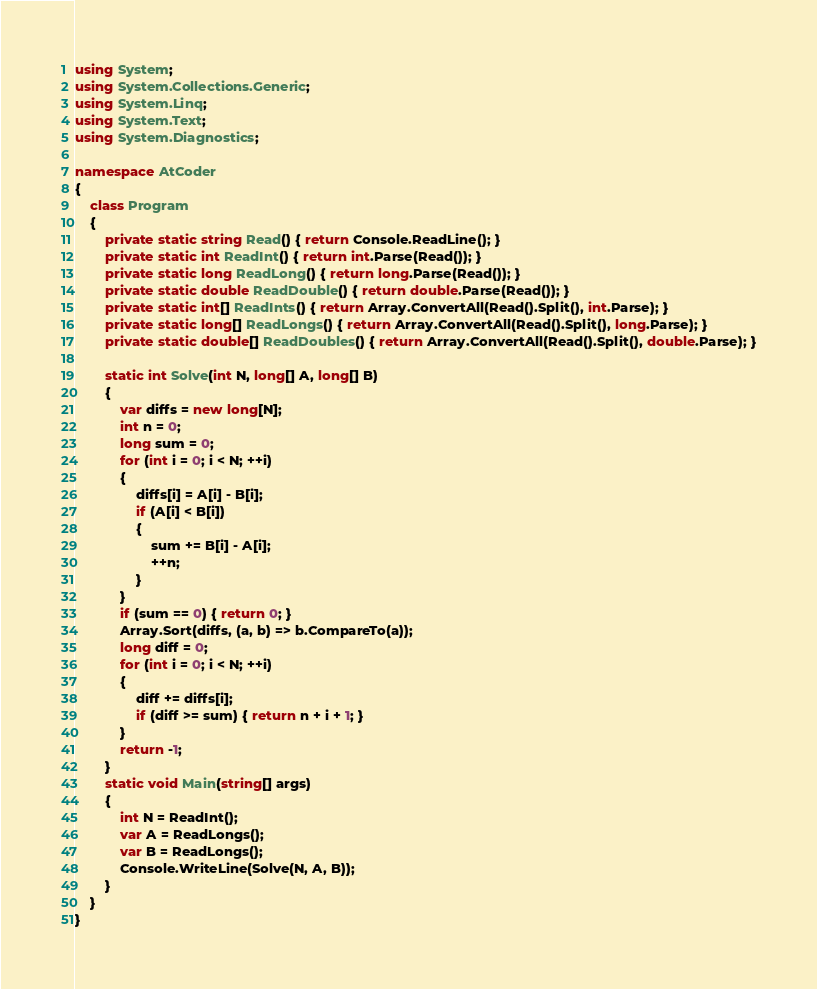Convert code to text. <code><loc_0><loc_0><loc_500><loc_500><_C#_>using System;
using System.Collections.Generic;
using System.Linq;
using System.Text;
using System.Diagnostics;

namespace AtCoder
{
    class Program
    {
        private static string Read() { return Console.ReadLine(); }
        private static int ReadInt() { return int.Parse(Read()); }
        private static long ReadLong() { return long.Parse(Read()); }
        private static double ReadDouble() { return double.Parse(Read()); }
        private static int[] ReadInts() { return Array.ConvertAll(Read().Split(), int.Parse); }
        private static long[] ReadLongs() { return Array.ConvertAll(Read().Split(), long.Parse); }
        private static double[] ReadDoubles() { return Array.ConvertAll(Read().Split(), double.Parse); }

        static int Solve(int N, long[] A, long[] B)
        {
            var diffs = new long[N];
            int n = 0;
            long sum = 0;
            for (int i = 0; i < N; ++i)
            {
                diffs[i] = A[i] - B[i];
                if (A[i] < B[i])
                {
                    sum += B[i] - A[i];
                    ++n;
                }
            }
            if (sum == 0) { return 0; }
            Array.Sort(diffs, (a, b) => b.CompareTo(a));
            long diff = 0;
            for (int i = 0; i < N; ++i)
            {
                diff += diffs[i];
                if (diff >= sum) { return n + i + 1; }
            }
            return -1;
        }
        static void Main(string[] args)
        {
            int N = ReadInt();
            var A = ReadLongs();
            var B = ReadLongs();
            Console.WriteLine(Solve(N, A, B));
        }
    }
}
</code> 